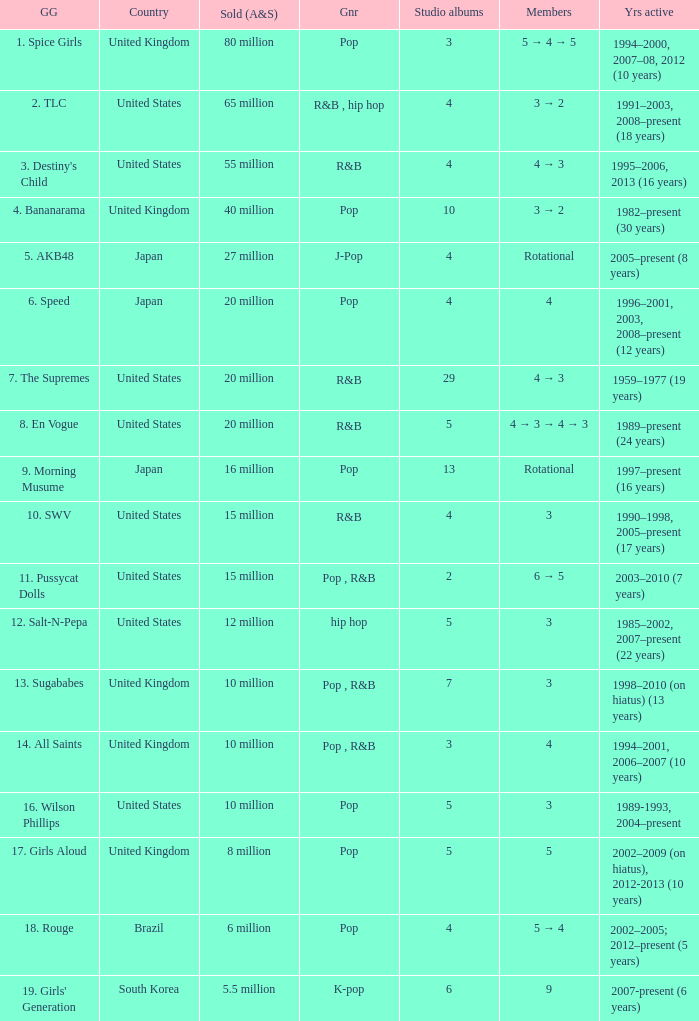What group had 29 studio albums? 7. The Supremes. 